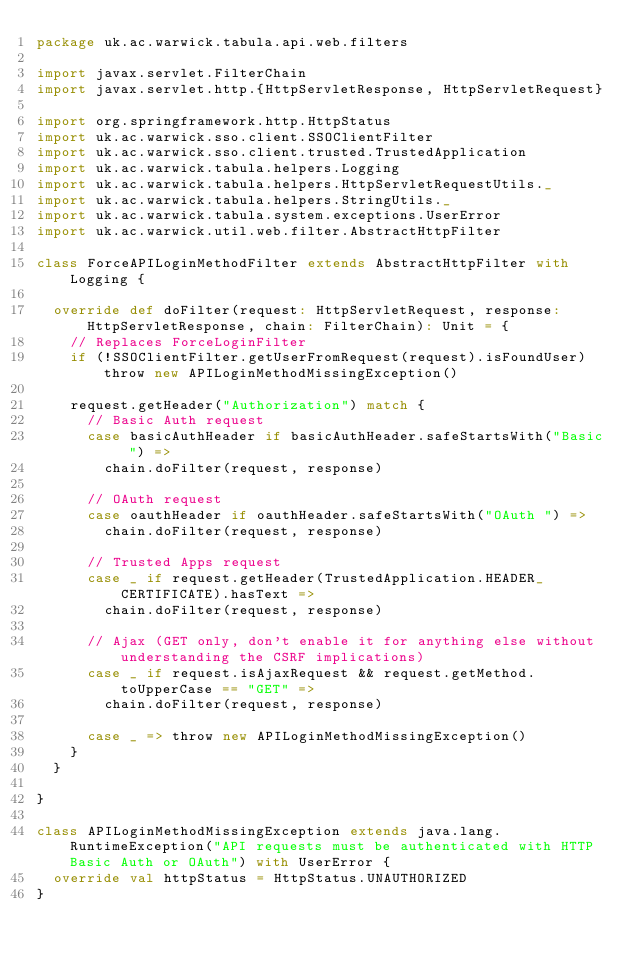Convert code to text. <code><loc_0><loc_0><loc_500><loc_500><_Scala_>package uk.ac.warwick.tabula.api.web.filters

import javax.servlet.FilterChain
import javax.servlet.http.{HttpServletResponse, HttpServletRequest}

import org.springframework.http.HttpStatus
import uk.ac.warwick.sso.client.SSOClientFilter
import uk.ac.warwick.sso.client.trusted.TrustedApplication
import uk.ac.warwick.tabula.helpers.Logging
import uk.ac.warwick.tabula.helpers.HttpServletRequestUtils._
import uk.ac.warwick.tabula.helpers.StringUtils._
import uk.ac.warwick.tabula.system.exceptions.UserError
import uk.ac.warwick.util.web.filter.AbstractHttpFilter

class ForceAPILoginMethodFilter extends AbstractHttpFilter with Logging {

  override def doFilter(request: HttpServletRequest, response: HttpServletResponse, chain: FilterChain): Unit = {
    // Replaces ForceLoginFilter
    if (!SSOClientFilter.getUserFromRequest(request).isFoundUser) throw new APILoginMethodMissingException()

    request.getHeader("Authorization") match {
      // Basic Auth request
      case basicAuthHeader if basicAuthHeader.safeStartsWith("Basic ") =>
        chain.doFilter(request, response)

      // OAuth request
      case oauthHeader if oauthHeader.safeStartsWith("OAuth ") =>
        chain.doFilter(request, response)

      // Trusted Apps request
      case _ if request.getHeader(TrustedApplication.HEADER_CERTIFICATE).hasText =>
        chain.doFilter(request, response)

      // Ajax (GET only, don't enable it for anything else without understanding the CSRF implications)
      case _ if request.isAjaxRequest && request.getMethod.toUpperCase == "GET" =>
        chain.doFilter(request, response)

      case _ => throw new APILoginMethodMissingException()
    }
  }

}

class APILoginMethodMissingException extends java.lang.RuntimeException("API requests must be authenticated with HTTP Basic Auth or OAuth") with UserError {
  override val httpStatus = HttpStatus.UNAUTHORIZED
}
</code> 